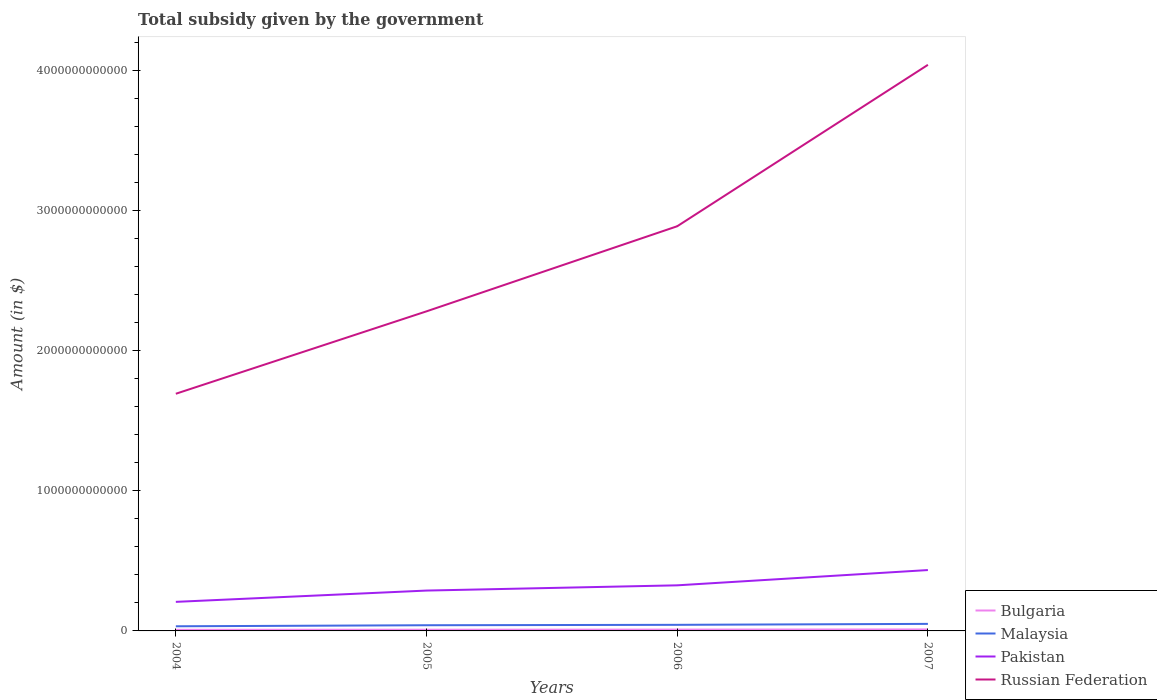How many different coloured lines are there?
Offer a terse response. 4. Across all years, what is the maximum total revenue collected by the government in Pakistan?
Your answer should be compact. 2.07e+11. What is the total total revenue collected by the government in Pakistan in the graph?
Offer a very short reply. -3.74e+1. What is the difference between the highest and the second highest total revenue collected by the government in Malaysia?
Offer a terse response. 1.71e+1. How many lines are there?
Your answer should be compact. 4. How many years are there in the graph?
Give a very brief answer. 4. What is the difference between two consecutive major ticks on the Y-axis?
Ensure brevity in your answer.  1.00e+12. Where does the legend appear in the graph?
Make the answer very short. Bottom right. How many legend labels are there?
Offer a very short reply. 4. How are the legend labels stacked?
Provide a succinct answer. Vertical. What is the title of the graph?
Ensure brevity in your answer.  Total subsidy given by the government. What is the label or title of the Y-axis?
Provide a short and direct response. Amount (in $). What is the Amount (in $) in Bulgaria in 2004?
Provide a short and direct response. 7.91e+09. What is the Amount (in $) of Malaysia in 2004?
Provide a succinct answer. 3.31e+1. What is the Amount (in $) in Pakistan in 2004?
Keep it short and to the point. 2.07e+11. What is the Amount (in $) of Russian Federation in 2004?
Ensure brevity in your answer.  1.69e+12. What is the Amount (in $) of Bulgaria in 2005?
Offer a very short reply. 8.53e+09. What is the Amount (in $) of Malaysia in 2005?
Your response must be concise. 4.06e+1. What is the Amount (in $) of Pakistan in 2005?
Keep it short and to the point. 2.88e+11. What is the Amount (in $) in Russian Federation in 2005?
Provide a succinct answer. 2.28e+12. What is the Amount (in $) of Bulgaria in 2006?
Your answer should be compact. 9.61e+09. What is the Amount (in $) in Malaysia in 2006?
Keep it short and to the point. 4.34e+1. What is the Amount (in $) of Pakistan in 2006?
Your answer should be compact. 3.25e+11. What is the Amount (in $) of Russian Federation in 2006?
Keep it short and to the point. 2.89e+12. What is the Amount (in $) in Bulgaria in 2007?
Provide a short and direct response. 1.06e+1. What is the Amount (in $) in Malaysia in 2007?
Keep it short and to the point. 5.02e+1. What is the Amount (in $) of Pakistan in 2007?
Keep it short and to the point. 4.34e+11. What is the Amount (in $) in Russian Federation in 2007?
Your response must be concise. 4.04e+12. Across all years, what is the maximum Amount (in $) in Bulgaria?
Your response must be concise. 1.06e+1. Across all years, what is the maximum Amount (in $) in Malaysia?
Provide a succinct answer. 5.02e+1. Across all years, what is the maximum Amount (in $) of Pakistan?
Your response must be concise. 4.34e+11. Across all years, what is the maximum Amount (in $) in Russian Federation?
Provide a short and direct response. 4.04e+12. Across all years, what is the minimum Amount (in $) in Bulgaria?
Offer a terse response. 7.91e+09. Across all years, what is the minimum Amount (in $) of Malaysia?
Offer a very short reply. 3.31e+1. Across all years, what is the minimum Amount (in $) of Pakistan?
Keep it short and to the point. 2.07e+11. Across all years, what is the minimum Amount (in $) of Russian Federation?
Your answer should be compact. 1.69e+12. What is the total Amount (in $) in Bulgaria in the graph?
Offer a very short reply. 3.66e+1. What is the total Amount (in $) in Malaysia in the graph?
Keep it short and to the point. 1.67e+11. What is the total Amount (in $) of Pakistan in the graph?
Give a very brief answer. 1.25e+12. What is the total Amount (in $) of Russian Federation in the graph?
Keep it short and to the point. 1.09e+13. What is the difference between the Amount (in $) in Bulgaria in 2004 and that in 2005?
Ensure brevity in your answer.  -6.22e+08. What is the difference between the Amount (in $) of Malaysia in 2004 and that in 2005?
Your response must be concise. -7.50e+09. What is the difference between the Amount (in $) in Pakistan in 2004 and that in 2005?
Keep it short and to the point. -8.06e+1. What is the difference between the Amount (in $) in Russian Federation in 2004 and that in 2005?
Your answer should be very brief. -5.88e+11. What is the difference between the Amount (in $) of Bulgaria in 2004 and that in 2006?
Provide a short and direct response. -1.71e+09. What is the difference between the Amount (in $) of Malaysia in 2004 and that in 2006?
Your answer should be compact. -1.03e+1. What is the difference between the Amount (in $) of Pakistan in 2004 and that in 2006?
Offer a very short reply. -1.18e+11. What is the difference between the Amount (in $) in Russian Federation in 2004 and that in 2006?
Provide a short and direct response. -1.19e+12. What is the difference between the Amount (in $) of Bulgaria in 2004 and that in 2007?
Make the answer very short. -2.66e+09. What is the difference between the Amount (in $) of Malaysia in 2004 and that in 2007?
Your answer should be compact. -1.71e+1. What is the difference between the Amount (in $) of Pakistan in 2004 and that in 2007?
Give a very brief answer. -2.27e+11. What is the difference between the Amount (in $) in Russian Federation in 2004 and that in 2007?
Ensure brevity in your answer.  -2.35e+12. What is the difference between the Amount (in $) in Bulgaria in 2005 and that in 2006?
Ensure brevity in your answer.  -1.09e+09. What is the difference between the Amount (in $) of Malaysia in 2005 and that in 2006?
Your answer should be compact. -2.79e+09. What is the difference between the Amount (in $) in Pakistan in 2005 and that in 2006?
Provide a succinct answer. -3.74e+1. What is the difference between the Amount (in $) of Russian Federation in 2005 and that in 2006?
Give a very brief answer. -6.07e+11. What is the difference between the Amount (in $) of Bulgaria in 2005 and that in 2007?
Your answer should be compact. -2.04e+09. What is the difference between the Amount (in $) of Malaysia in 2005 and that in 2007?
Make the answer very short. -9.61e+09. What is the difference between the Amount (in $) in Pakistan in 2005 and that in 2007?
Give a very brief answer. -1.46e+11. What is the difference between the Amount (in $) of Russian Federation in 2005 and that in 2007?
Your answer should be compact. -1.76e+12. What is the difference between the Amount (in $) in Bulgaria in 2006 and that in 2007?
Offer a very short reply. -9.55e+08. What is the difference between the Amount (in $) of Malaysia in 2006 and that in 2007?
Your response must be concise. -6.82e+09. What is the difference between the Amount (in $) in Pakistan in 2006 and that in 2007?
Ensure brevity in your answer.  -1.09e+11. What is the difference between the Amount (in $) of Russian Federation in 2006 and that in 2007?
Keep it short and to the point. -1.15e+12. What is the difference between the Amount (in $) in Bulgaria in 2004 and the Amount (in $) in Malaysia in 2005?
Provide a succinct answer. -3.27e+1. What is the difference between the Amount (in $) in Bulgaria in 2004 and the Amount (in $) in Pakistan in 2005?
Offer a very short reply. -2.80e+11. What is the difference between the Amount (in $) of Bulgaria in 2004 and the Amount (in $) of Russian Federation in 2005?
Your response must be concise. -2.27e+12. What is the difference between the Amount (in $) in Malaysia in 2004 and the Amount (in $) in Pakistan in 2005?
Provide a short and direct response. -2.55e+11. What is the difference between the Amount (in $) of Malaysia in 2004 and the Amount (in $) of Russian Federation in 2005?
Your response must be concise. -2.25e+12. What is the difference between the Amount (in $) in Pakistan in 2004 and the Amount (in $) in Russian Federation in 2005?
Make the answer very short. -2.07e+12. What is the difference between the Amount (in $) of Bulgaria in 2004 and the Amount (in $) of Malaysia in 2006?
Make the answer very short. -3.55e+1. What is the difference between the Amount (in $) of Bulgaria in 2004 and the Amount (in $) of Pakistan in 2006?
Ensure brevity in your answer.  -3.17e+11. What is the difference between the Amount (in $) in Bulgaria in 2004 and the Amount (in $) in Russian Federation in 2006?
Give a very brief answer. -2.88e+12. What is the difference between the Amount (in $) of Malaysia in 2004 and the Amount (in $) of Pakistan in 2006?
Keep it short and to the point. -2.92e+11. What is the difference between the Amount (in $) of Malaysia in 2004 and the Amount (in $) of Russian Federation in 2006?
Provide a short and direct response. -2.85e+12. What is the difference between the Amount (in $) of Pakistan in 2004 and the Amount (in $) of Russian Federation in 2006?
Provide a short and direct response. -2.68e+12. What is the difference between the Amount (in $) of Bulgaria in 2004 and the Amount (in $) of Malaysia in 2007?
Offer a very short reply. -4.23e+1. What is the difference between the Amount (in $) in Bulgaria in 2004 and the Amount (in $) in Pakistan in 2007?
Your answer should be very brief. -4.26e+11. What is the difference between the Amount (in $) in Bulgaria in 2004 and the Amount (in $) in Russian Federation in 2007?
Your answer should be compact. -4.03e+12. What is the difference between the Amount (in $) in Malaysia in 2004 and the Amount (in $) in Pakistan in 2007?
Offer a very short reply. -4.01e+11. What is the difference between the Amount (in $) in Malaysia in 2004 and the Amount (in $) in Russian Federation in 2007?
Make the answer very short. -4.01e+12. What is the difference between the Amount (in $) of Pakistan in 2004 and the Amount (in $) of Russian Federation in 2007?
Your answer should be compact. -3.83e+12. What is the difference between the Amount (in $) in Bulgaria in 2005 and the Amount (in $) in Malaysia in 2006?
Offer a very short reply. -3.49e+1. What is the difference between the Amount (in $) in Bulgaria in 2005 and the Amount (in $) in Pakistan in 2006?
Your answer should be very brief. -3.17e+11. What is the difference between the Amount (in $) in Bulgaria in 2005 and the Amount (in $) in Russian Federation in 2006?
Your answer should be very brief. -2.88e+12. What is the difference between the Amount (in $) of Malaysia in 2005 and the Amount (in $) of Pakistan in 2006?
Offer a terse response. -2.85e+11. What is the difference between the Amount (in $) of Malaysia in 2005 and the Amount (in $) of Russian Federation in 2006?
Your answer should be very brief. -2.85e+12. What is the difference between the Amount (in $) of Pakistan in 2005 and the Amount (in $) of Russian Federation in 2006?
Your answer should be compact. -2.60e+12. What is the difference between the Amount (in $) in Bulgaria in 2005 and the Amount (in $) in Malaysia in 2007?
Ensure brevity in your answer.  -4.17e+1. What is the difference between the Amount (in $) in Bulgaria in 2005 and the Amount (in $) in Pakistan in 2007?
Offer a very short reply. -4.26e+11. What is the difference between the Amount (in $) in Bulgaria in 2005 and the Amount (in $) in Russian Federation in 2007?
Give a very brief answer. -4.03e+12. What is the difference between the Amount (in $) in Malaysia in 2005 and the Amount (in $) in Pakistan in 2007?
Give a very brief answer. -3.94e+11. What is the difference between the Amount (in $) in Malaysia in 2005 and the Amount (in $) in Russian Federation in 2007?
Ensure brevity in your answer.  -4.00e+12. What is the difference between the Amount (in $) in Pakistan in 2005 and the Amount (in $) in Russian Federation in 2007?
Offer a very short reply. -3.75e+12. What is the difference between the Amount (in $) in Bulgaria in 2006 and the Amount (in $) in Malaysia in 2007?
Offer a very short reply. -4.06e+1. What is the difference between the Amount (in $) in Bulgaria in 2006 and the Amount (in $) in Pakistan in 2007?
Keep it short and to the point. -4.25e+11. What is the difference between the Amount (in $) in Bulgaria in 2006 and the Amount (in $) in Russian Federation in 2007?
Your response must be concise. -4.03e+12. What is the difference between the Amount (in $) of Malaysia in 2006 and the Amount (in $) of Pakistan in 2007?
Make the answer very short. -3.91e+11. What is the difference between the Amount (in $) of Malaysia in 2006 and the Amount (in $) of Russian Federation in 2007?
Your answer should be very brief. -4.00e+12. What is the difference between the Amount (in $) of Pakistan in 2006 and the Amount (in $) of Russian Federation in 2007?
Provide a succinct answer. -3.71e+12. What is the average Amount (in $) in Bulgaria per year?
Offer a terse response. 9.15e+09. What is the average Amount (in $) of Malaysia per year?
Your answer should be compact. 4.18e+1. What is the average Amount (in $) in Pakistan per year?
Keep it short and to the point. 3.14e+11. What is the average Amount (in $) of Russian Federation per year?
Make the answer very short. 2.72e+12. In the year 2004, what is the difference between the Amount (in $) in Bulgaria and Amount (in $) in Malaysia?
Give a very brief answer. -2.52e+1. In the year 2004, what is the difference between the Amount (in $) in Bulgaria and Amount (in $) in Pakistan?
Provide a succinct answer. -1.99e+11. In the year 2004, what is the difference between the Amount (in $) in Bulgaria and Amount (in $) in Russian Federation?
Keep it short and to the point. -1.68e+12. In the year 2004, what is the difference between the Amount (in $) in Malaysia and Amount (in $) in Pakistan?
Give a very brief answer. -1.74e+11. In the year 2004, what is the difference between the Amount (in $) in Malaysia and Amount (in $) in Russian Federation?
Offer a terse response. -1.66e+12. In the year 2004, what is the difference between the Amount (in $) in Pakistan and Amount (in $) in Russian Federation?
Keep it short and to the point. -1.48e+12. In the year 2005, what is the difference between the Amount (in $) in Bulgaria and Amount (in $) in Malaysia?
Your answer should be very brief. -3.21e+1. In the year 2005, what is the difference between the Amount (in $) in Bulgaria and Amount (in $) in Pakistan?
Offer a terse response. -2.79e+11. In the year 2005, what is the difference between the Amount (in $) in Bulgaria and Amount (in $) in Russian Federation?
Your answer should be compact. -2.27e+12. In the year 2005, what is the difference between the Amount (in $) of Malaysia and Amount (in $) of Pakistan?
Offer a terse response. -2.47e+11. In the year 2005, what is the difference between the Amount (in $) of Malaysia and Amount (in $) of Russian Federation?
Ensure brevity in your answer.  -2.24e+12. In the year 2005, what is the difference between the Amount (in $) in Pakistan and Amount (in $) in Russian Federation?
Provide a succinct answer. -1.99e+12. In the year 2006, what is the difference between the Amount (in $) in Bulgaria and Amount (in $) in Malaysia?
Ensure brevity in your answer.  -3.38e+1. In the year 2006, what is the difference between the Amount (in $) in Bulgaria and Amount (in $) in Pakistan?
Your answer should be very brief. -3.16e+11. In the year 2006, what is the difference between the Amount (in $) of Bulgaria and Amount (in $) of Russian Federation?
Your response must be concise. -2.88e+12. In the year 2006, what is the difference between the Amount (in $) of Malaysia and Amount (in $) of Pakistan?
Your response must be concise. -2.82e+11. In the year 2006, what is the difference between the Amount (in $) of Malaysia and Amount (in $) of Russian Federation?
Provide a short and direct response. -2.84e+12. In the year 2006, what is the difference between the Amount (in $) of Pakistan and Amount (in $) of Russian Federation?
Provide a succinct answer. -2.56e+12. In the year 2007, what is the difference between the Amount (in $) in Bulgaria and Amount (in $) in Malaysia?
Make the answer very short. -3.97e+1. In the year 2007, what is the difference between the Amount (in $) in Bulgaria and Amount (in $) in Pakistan?
Ensure brevity in your answer.  -4.24e+11. In the year 2007, what is the difference between the Amount (in $) of Bulgaria and Amount (in $) of Russian Federation?
Offer a very short reply. -4.03e+12. In the year 2007, what is the difference between the Amount (in $) of Malaysia and Amount (in $) of Pakistan?
Provide a short and direct response. -3.84e+11. In the year 2007, what is the difference between the Amount (in $) of Malaysia and Amount (in $) of Russian Federation?
Offer a terse response. -3.99e+12. In the year 2007, what is the difference between the Amount (in $) of Pakistan and Amount (in $) of Russian Federation?
Your response must be concise. -3.60e+12. What is the ratio of the Amount (in $) of Bulgaria in 2004 to that in 2005?
Offer a very short reply. 0.93. What is the ratio of the Amount (in $) of Malaysia in 2004 to that in 2005?
Your answer should be very brief. 0.82. What is the ratio of the Amount (in $) of Pakistan in 2004 to that in 2005?
Keep it short and to the point. 0.72. What is the ratio of the Amount (in $) of Russian Federation in 2004 to that in 2005?
Your answer should be very brief. 0.74. What is the ratio of the Amount (in $) of Bulgaria in 2004 to that in 2006?
Provide a short and direct response. 0.82. What is the ratio of the Amount (in $) of Malaysia in 2004 to that in 2006?
Ensure brevity in your answer.  0.76. What is the ratio of the Amount (in $) in Pakistan in 2004 to that in 2006?
Your response must be concise. 0.64. What is the ratio of the Amount (in $) of Russian Federation in 2004 to that in 2006?
Give a very brief answer. 0.59. What is the ratio of the Amount (in $) in Bulgaria in 2004 to that in 2007?
Your answer should be very brief. 0.75. What is the ratio of the Amount (in $) in Malaysia in 2004 to that in 2007?
Keep it short and to the point. 0.66. What is the ratio of the Amount (in $) of Pakistan in 2004 to that in 2007?
Your response must be concise. 0.48. What is the ratio of the Amount (in $) in Russian Federation in 2004 to that in 2007?
Give a very brief answer. 0.42. What is the ratio of the Amount (in $) of Bulgaria in 2005 to that in 2006?
Provide a succinct answer. 0.89. What is the ratio of the Amount (in $) of Malaysia in 2005 to that in 2006?
Your answer should be very brief. 0.94. What is the ratio of the Amount (in $) in Pakistan in 2005 to that in 2006?
Provide a succinct answer. 0.89. What is the ratio of the Amount (in $) in Russian Federation in 2005 to that in 2006?
Keep it short and to the point. 0.79. What is the ratio of the Amount (in $) in Bulgaria in 2005 to that in 2007?
Make the answer very short. 0.81. What is the ratio of the Amount (in $) in Malaysia in 2005 to that in 2007?
Give a very brief answer. 0.81. What is the ratio of the Amount (in $) in Pakistan in 2005 to that in 2007?
Make the answer very short. 0.66. What is the ratio of the Amount (in $) of Russian Federation in 2005 to that in 2007?
Make the answer very short. 0.56. What is the ratio of the Amount (in $) of Bulgaria in 2006 to that in 2007?
Your answer should be compact. 0.91. What is the ratio of the Amount (in $) in Malaysia in 2006 to that in 2007?
Offer a very short reply. 0.86. What is the ratio of the Amount (in $) of Pakistan in 2006 to that in 2007?
Offer a terse response. 0.75. What is the ratio of the Amount (in $) in Russian Federation in 2006 to that in 2007?
Offer a terse response. 0.71. What is the difference between the highest and the second highest Amount (in $) of Bulgaria?
Your answer should be compact. 9.55e+08. What is the difference between the highest and the second highest Amount (in $) in Malaysia?
Keep it short and to the point. 6.82e+09. What is the difference between the highest and the second highest Amount (in $) in Pakistan?
Your response must be concise. 1.09e+11. What is the difference between the highest and the second highest Amount (in $) in Russian Federation?
Ensure brevity in your answer.  1.15e+12. What is the difference between the highest and the lowest Amount (in $) in Bulgaria?
Offer a terse response. 2.66e+09. What is the difference between the highest and the lowest Amount (in $) of Malaysia?
Your answer should be very brief. 1.71e+1. What is the difference between the highest and the lowest Amount (in $) of Pakistan?
Your response must be concise. 2.27e+11. What is the difference between the highest and the lowest Amount (in $) of Russian Federation?
Make the answer very short. 2.35e+12. 